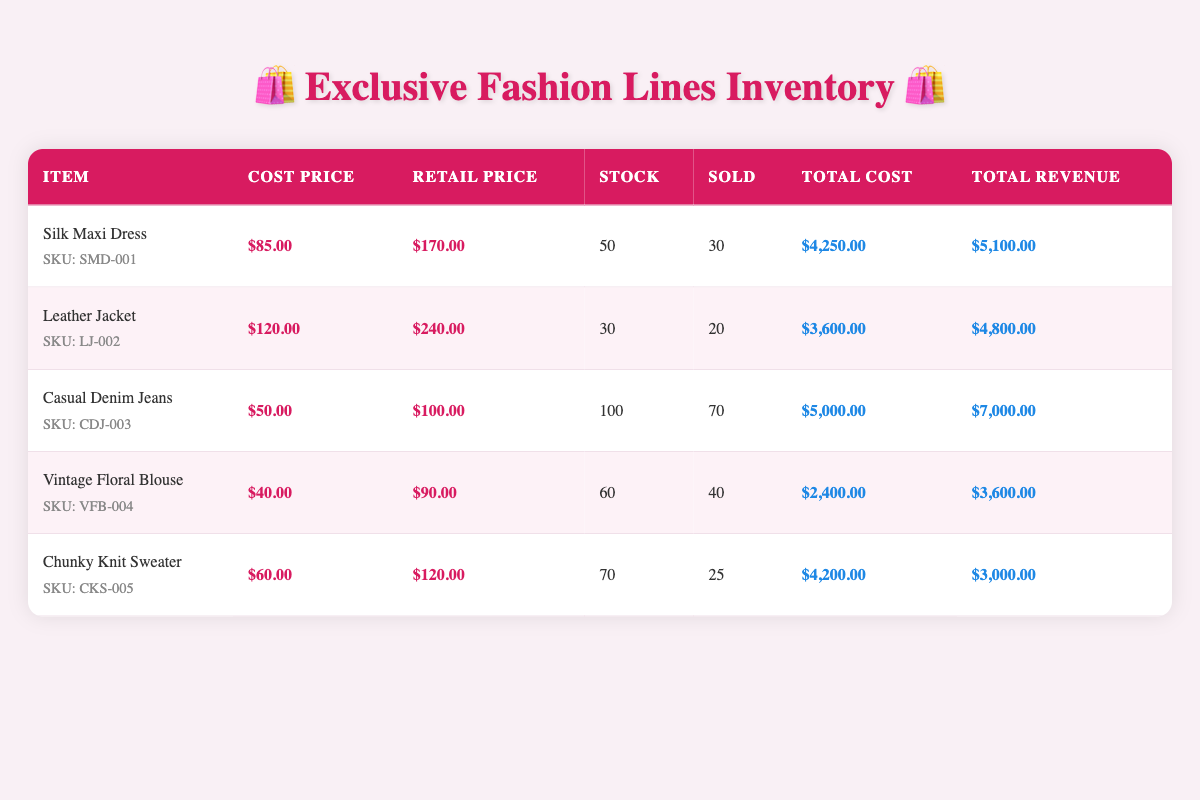What is the total revenue for the Casual Denim Jeans? The total revenue for the Casual Denim Jeans is listed in the table as $7,000.00.
Answer: $7,000.00 How many units of the Silk Maxi Dress are still in stock? The table shows that there are 50 units of the Silk Maxi Dress currently in stock.
Answer: 50 What is the profit for the Leather Jacket? To find the profit, subtract the total cost from the total revenue: $4,800.00 (revenue) - $3,600.00 (cost) = $1,200.00.
Answer: $1,200.00 Are there more units of the Vintage Floral Blouse sold than the Chunky Knit Sweater? The table indicates that 40 units of the Vintage Floral Blouse were sold, while 25 units of the Chunky Knit Sweater were sold. Thus, it is true that more units of the Vintage Floral Blouse were sold.
Answer: Yes What is the average cost price of all items listed in the inventory? To find the average, sum all the cost prices: $85.00 + $120.00 + $50.00 + $40.00 + $60.00 = $355.00. Then divide by the number of items (5): $355.00 / 5 = $71.00.
Answer: $71.00 What is the total value of inventory for all items listed? The total value of inventory is calculated by summing the total cost of all items: $4,250.00 + $3,600.00 + $5,000.00 + $2,400.00 + $4,200.00 = $19,450.00.
Answer: $19,450.00 Which item has the highest retail price? By examining the table, the Leather Jacket has the highest retail price at $240.00, compared to others.
Answer: Leather Jacket How many more units of the Casual Denim Jeans were sold compared to the Chunky Knit Sweater? The Casual Denim Jeans sold 70 units, and the Chunky Knit Sweater sold 25 units. The difference is 70 - 25 = 45 units.
Answer: 45 units Is the total revenue for the Chunky Knit Sweater greater than its total cost? The table shows total revenue for the Chunky Knit Sweater as $3,000.00 and total cost as $4,200.00. Therefore, it is not greater.
Answer: No 